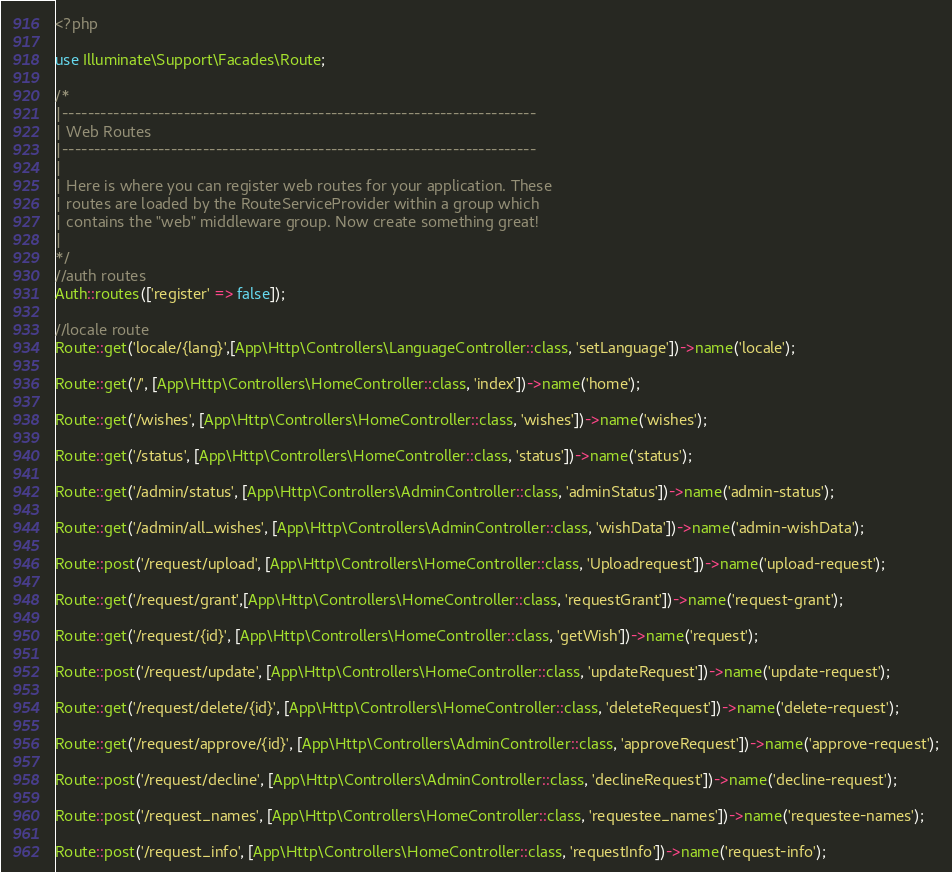Convert code to text. <code><loc_0><loc_0><loc_500><loc_500><_PHP_><?php

use Illuminate\Support\Facades\Route;

/*
|--------------------------------------------------------------------------
| Web Routes
|--------------------------------------------------------------------------
|
| Here is where you can register web routes for your application. These
| routes are loaded by the RouteServiceProvider within a group which
| contains the "web" middleware group. Now create something great!
|
*/
//auth routes
Auth::routes(['register' => false]);

//locale route
Route::get('locale/{lang}',[App\Http\Controllers\LanguageController::class, 'setLanguage'])->name('locale');

Route::get('/', [App\Http\Controllers\HomeController::class, 'index'])->name('home');

Route::get('/wishes', [App\Http\Controllers\HomeController::class, 'wishes'])->name('wishes');

Route::get('/status', [App\Http\Controllers\HomeController::class, 'status'])->name('status');

Route::get('/admin/status', [App\Http\Controllers\AdminController::class, 'adminStatus'])->name('admin-status');

Route::get('/admin/all_wishes', [App\Http\Controllers\AdminController::class, 'wishData'])->name('admin-wishData');

Route::post('/request/upload', [App\Http\Controllers\HomeController::class, 'Uploadrequest'])->name('upload-request');

Route::get('/request/grant',[App\Http\Controllers\HomeController::class, 'requestGrant'])->name('request-grant');

Route::get('/request/{id}', [App\Http\Controllers\HomeController::class, 'getWish'])->name('request');

Route::post('/request/update', [App\Http\Controllers\HomeController::class, 'updateRequest'])->name('update-request');

Route::get('/request/delete/{id}', [App\Http\Controllers\HomeController::class, 'deleteRequest'])->name('delete-request');

Route::get('/request/approve/{id}', [App\Http\Controllers\AdminController::class, 'approveRequest'])->name('approve-request');

Route::post('/request/decline', [App\Http\Controllers\AdminController::class, 'declineRequest'])->name('decline-request');

Route::post('/request_names', [App\Http\Controllers\HomeController::class, 'requestee_names'])->name('requestee-names');

Route::post('/request_info', [App\Http\Controllers\HomeController::class, 'requestInfo'])->name('request-info');
</code> 